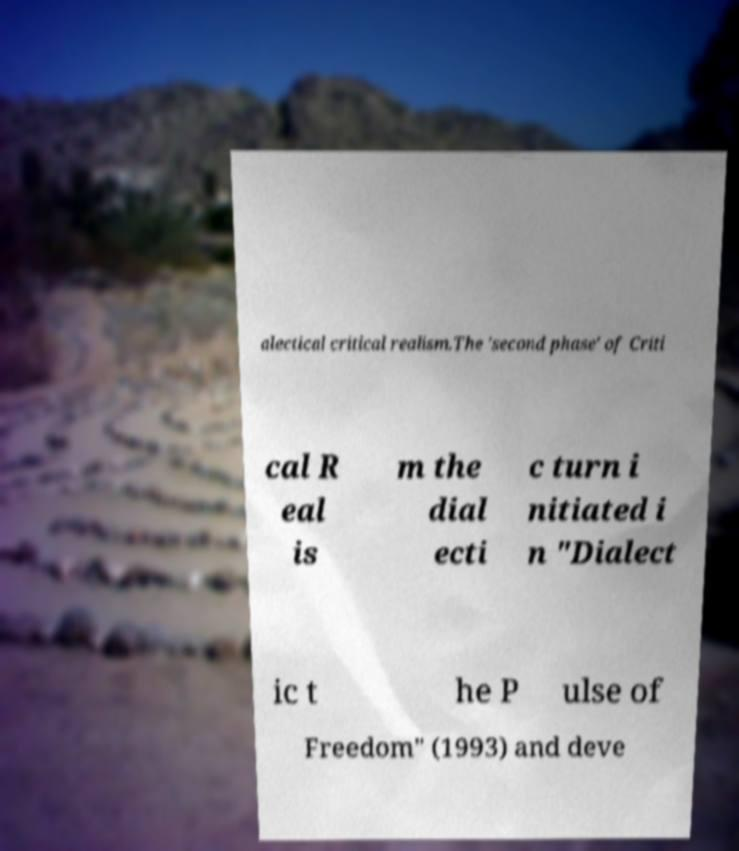What messages or text are displayed in this image? I need them in a readable, typed format. alectical critical realism.The 'second phase' of Criti cal R eal is m the dial ecti c turn i nitiated i n "Dialect ic t he P ulse of Freedom" (1993) and deve 